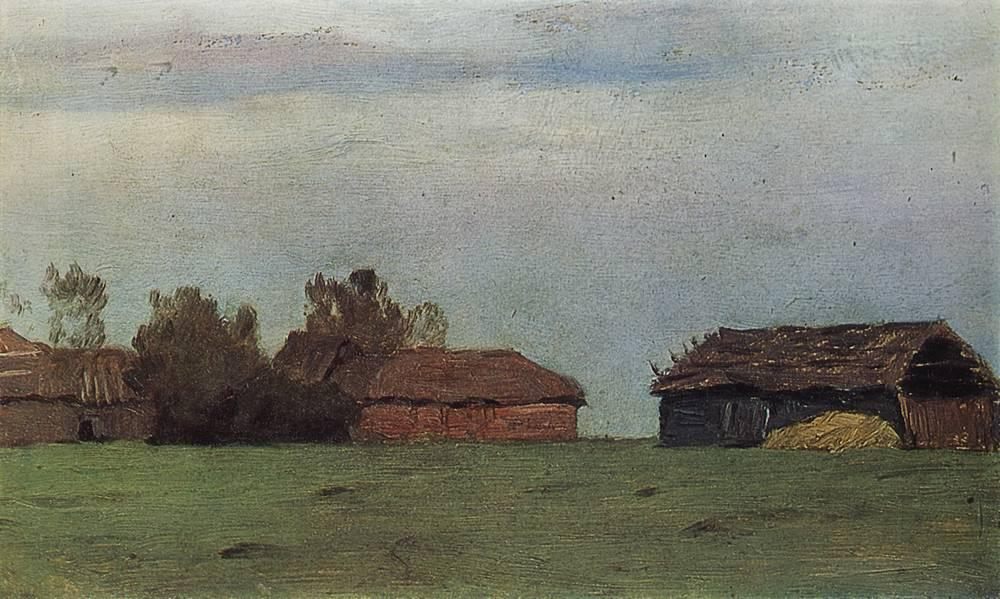What's happening in the scene? The painting depicts a tranquil rural landscape with a serene atmosphere. In the foreground, fields of lush green grass stretch towards a cluster of farm buildings. These structures are in various stages of disrepair, suggesting they have weathered the passage of time. The sky above is a pale blue, adorned with wispy clouds, adding depth to the scene. The painting's impressionistic style, with its loose brushstrokes and muted colors, conveys a sense of softness and subtlety. The absence of any human figures enhances the solitude and peacefulness of the scene. This artwork seems to draw inspiration from the Impressionist movement, which often focused on capturing fleeting moments of light and color. 